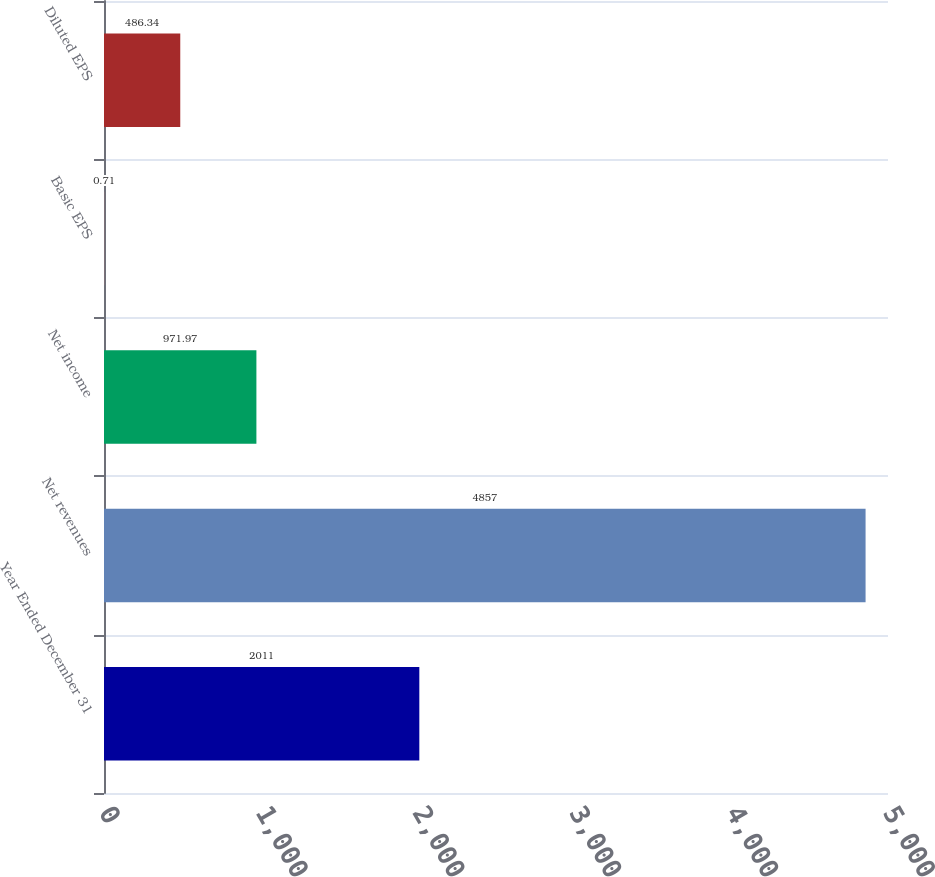<chart> <loc_0><loc_0><loc_500><loc_500><bar_chart><fcel>Year Ended December 31<fcel>Net revenues<fcel>Net income<fcel>Basic EPS<fcel>Diluted EPS<nl><fcel>2011<fcel>4857<fcel>971.97<fcel>0.71<fcel>486.34<nl></chart> 